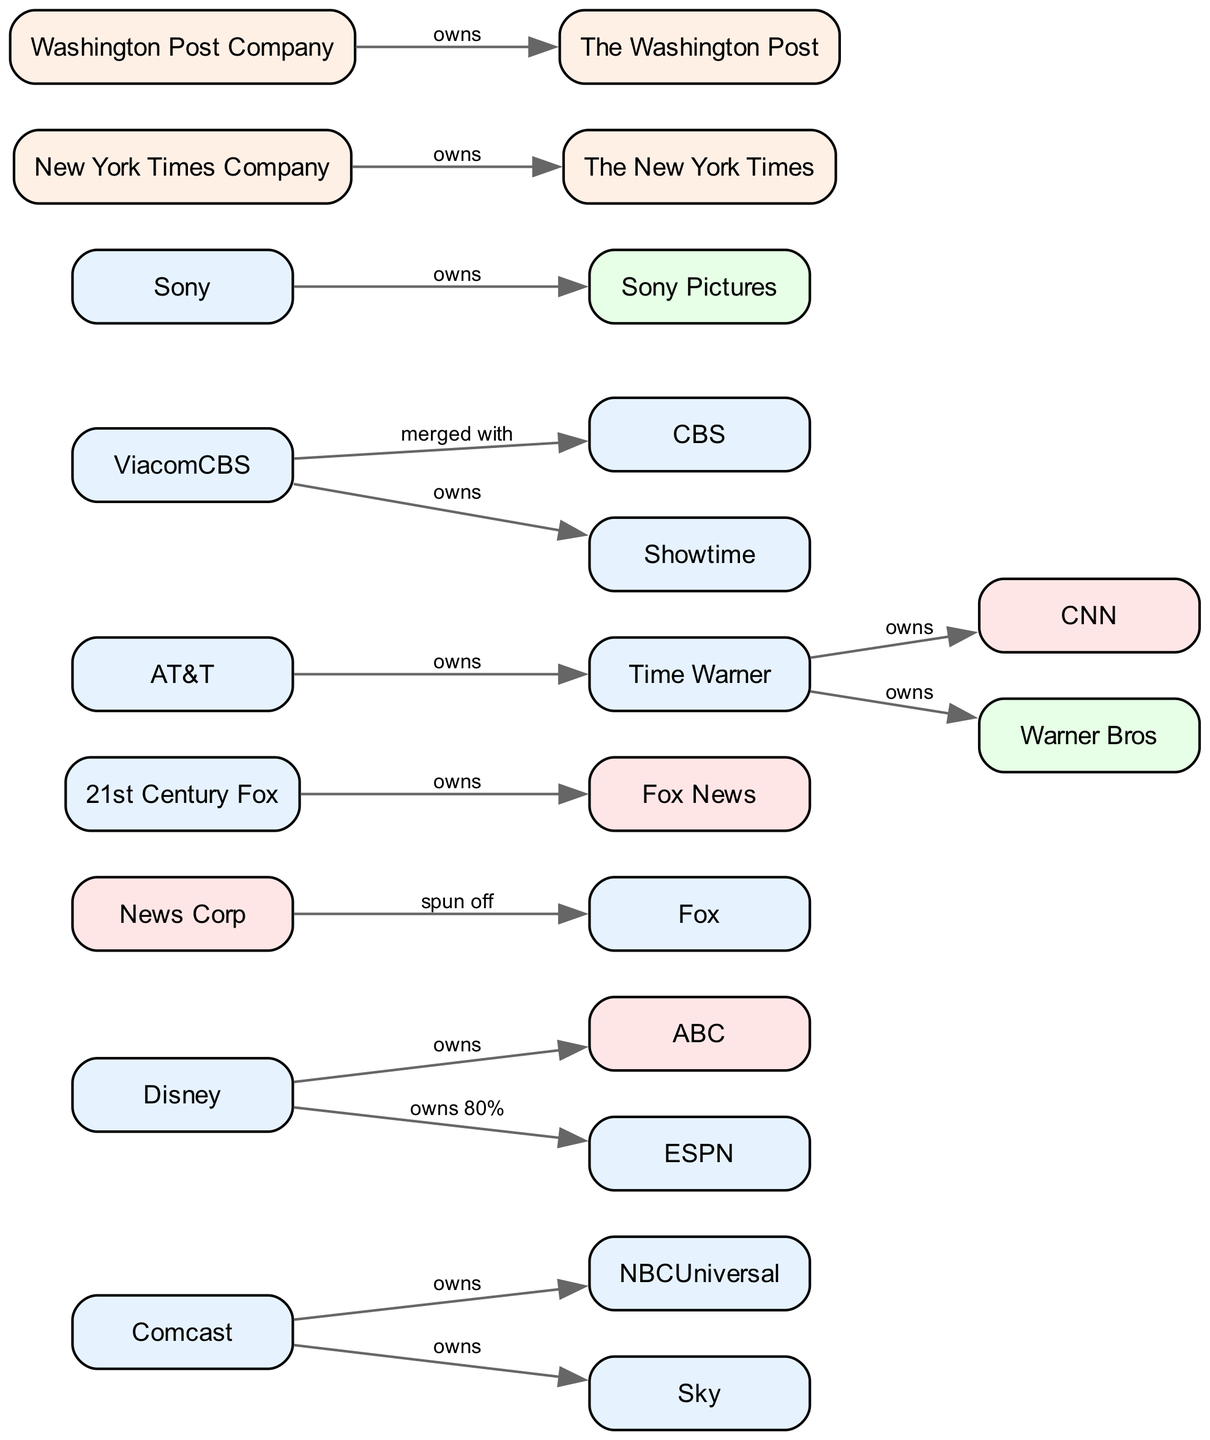What company owns NBCUniversal? The diagram shows a direct ownership relationship where Comcast is connected to NBCUniversal with an "owns" label. This indicates that Comcast is the owner of NBCUniversal.
Answer: Comcast How many media outlets are owned by Disney? By examining the edges connected to Disney, it shows two connections: one to ABC and one to ESPN. Therefore, Disney owns two media outlets, which makes the total count two.
Answer: 2 Which company merged with CBS? The edge connecting ViacomCBS to CBS is labeled "merged with," indicating that CBS is part of the ViacomCBS conglomerate due to their merger.
Answer: ViacomCBS Who owns the Washington Post? The edge from Washington Post Company to Washington Post is labeled "owns," meaning that the Washington Post Company directly owns The Washington Post.
Answer: Washington Post Company Which two companies own CNN? Looking through the diagram, TimeWarner is the owner of CNN, as illustrated by the direction of the edge linking them with the label "owns." No other owner is indicated directly on the diagram based on the provided edges.
Answer: TimeWarner What is the total number of nodes in the diagram? The total count of nodes corresponds to the number of different entities shown in the diagram, which is 22 based on the provided data.
Answer: 22 Which media outlet was spun off by News Corporation? The edge from NewsCorp to Fox indicates a relationship labeled "spun off," showing that Fox is the result of News Corporation's action of spinning it off.
Answer: Fox What percentage of ESPN does Disney own? The edge connecting Disney to ESPN is labeled "owns 80%," clearly indicating that Disney has an 80% ownership stake in ESPN.
Answer: 80% How many edges are there in the diagram? The edges represent the ownership relationships between nodes. By counting the edges listed in the data, there are a total of 15 edges.
Answer: 15 